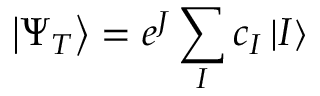Convert formula to latex. <formula><loc_0><loc_0><loc_500><loc_500>\left | { \Psi _ { T } } \right \rangle = e ^ { J } \sum _ { I } c _ { I } \left | { I } \right \rangle</formula> 